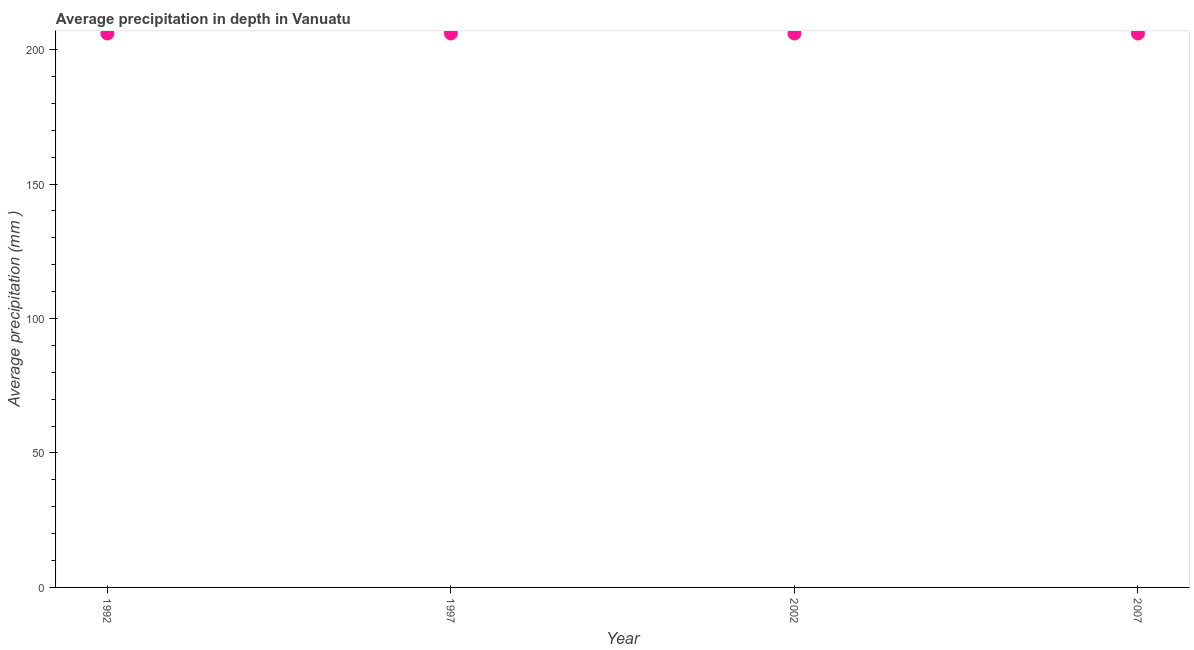What is the average precipitation in depth in 1997?
Ensure brevity in your answer.  206. Across all years, what is the maximum average precipitation in depth?
Your answer should be very brief. 206. Across all years, what is the minimum average precipitation in depth?
Your response must be concise. 206. In which year was the average precipitation in depth maximum?
Make the answer very short. 1992. In which year was the average precipitation in depth minimum?
Your answer should be compact. 1992. What is the sum of the average precipitation in depth?
Your response must be concise. 824. What is the difference between the average precipitation in depth in 1992 and 2007?
Ensure brevity in your answer.  0. What is the average average precipitation in depth per year?
Your answer should be very brief. 206. What is the median average precipitation in depth?
Your answer should be compact. 206. Is the average precipitation in depth in 1992 less than that in 2002?
Ensure brevity in your answer.  No. In how many years, is the average precipitation in depth greater than the average average precipitation in depth taken over all years?
Keep it short and to the point. 0. Does the average precipitation in depth monotonically increase over the years?
Your response must be concise. No. How many dotlines are there?
Ensure brevity in your answer.  1. Are the values on the major ticks of Y-axis written in scientific E-notation?
Your answer should be very brief. No. What is the title of the graph?
Provide a succinct answer. Average precipitation in depth in Vanuatu. What is the label or title of the X-axis?
Provide a short and direct response. Year. What is the label or title of the Y-axis?
Provide a short and direct response. Average precipitation (mm ). What is the Average precipitation (mm ) in 1992?
Provide a short and direct response. 206. What is the Average precipitation (mm ) in 1997?
Your answer should be very brief. 206. What is the Average precipitation (mm ) in 2002?
Your response must be concise. 206. What is the Average precipitation (mm ) in 2007?
Make the answer very short. 206. What is the difference between the Average precipitation (mm ) in 1992 and 2002?
Offer a very short reply. 0. What is the difference between the Average precipitation (mm ) in 1992 and 2007?
Offer a terse response. 0. What is the difference between the Average precipitation (mm ) in 1997 and 2007?
Make the answer very short. 0. What is the ratio of the Average precipitation (mm ) in 1992 to that in 2007?
Keep it short and to the point. 1. What is the ratio of the Average precipitation (mm ) in 1997 to that in 2002?
Make the answer very short. 1. What is the ratio of the Average precipitation (mm ) in 1997 to that in 2007?
Ensure brevity in your answer.  1. What is the ratio of the Average precipitation (mm ) in 2002 to that in 2007?
Give a very brief answer. 1. 